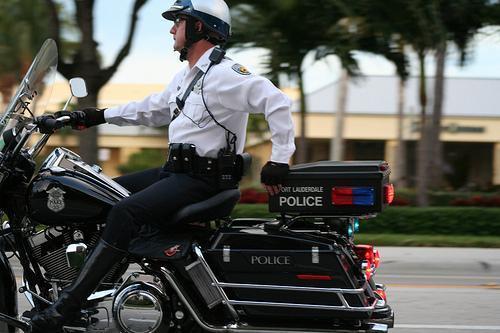How many people are on the bike?
Give a very brief answer. 1. 